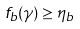<formula> <loc_0><loc_0><loc_500><loc_500>f _ { b } ( \gamma ) \geq \eta _ { b }</formula> 